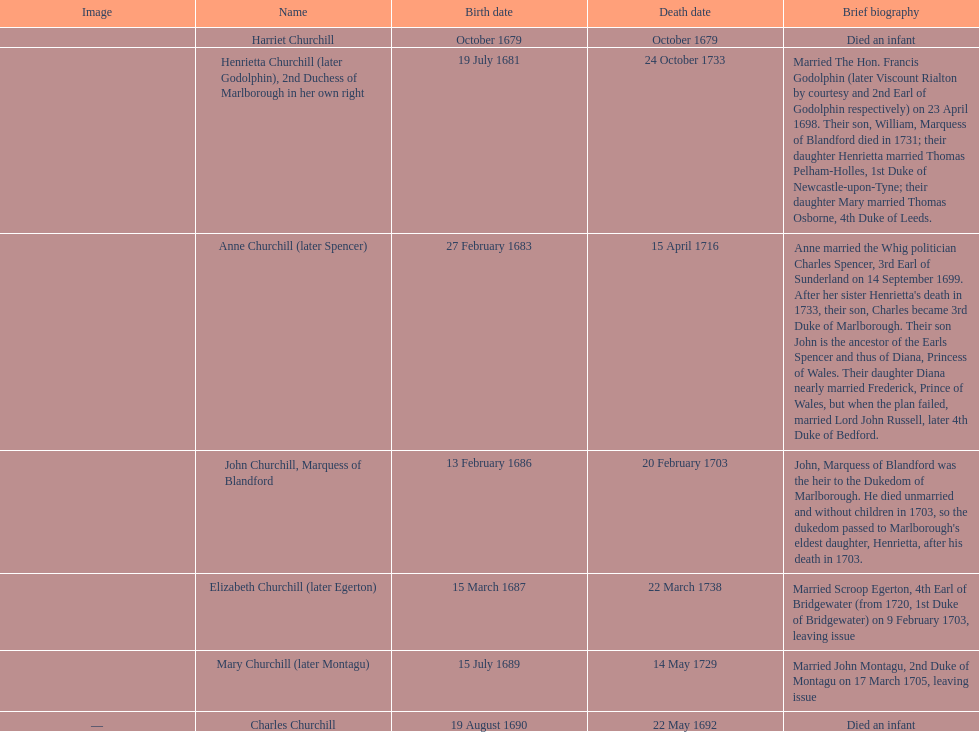Which child was the first to die? Harriet Churchill. 